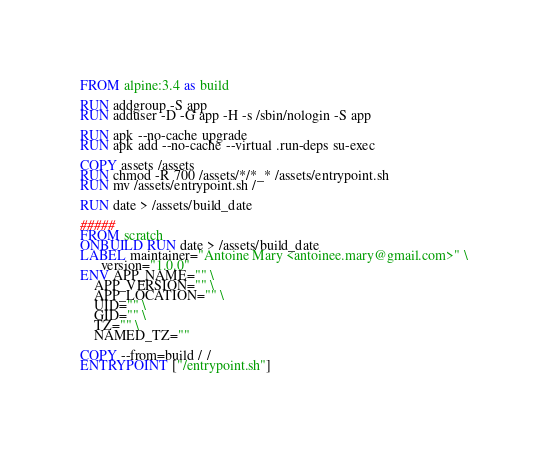<code> <loc_0><loc_0><loc_500><loc_500><_Dockerfile_>FROM alpine:3.4 as build

RUN addgroup -S app
RUN adduser -D -G app -H -s /sbin/nologin -S app

RUN apk --no-cache upgrade
RUN apk add --no-cache --virtual .run-deps su-exec

COPY assets /assets
RUN chmod -R 700 /assets/*/*_* /assets/entrypoint.sh
RUN mv /assets/entrypoint.sh /

RUN date > /assets/build_date

#####
FROM scratch
ONBUILD RUN date > /assets/build_date
LABEL maintainer="Antoine Mary <antoinee.mary@gmail.com>" \
      version="1.0.0"
ENV APP_NAME="" \
    APP_VERSION="" \
    APP_LOCATION="" \
    UID="" \
    GID="" \
    TZ="" \
    NAMED_TZ=""

COPY --from=build / /
ENTRYPOINT ["/entrypoint.sh"]
</code> 